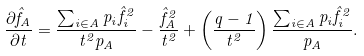Convert formula to latex. <formula><loc_0><loc_0><loc_500><loc_500>\frac { \partial \hat { f } _ { A } } { \partial t } = \frac { \sum _ { i \in A } p _ { i } \hat { f } _ { i } ^ { 2 } } { t ^ { 2 } p _ { A } } - \frac { \hat { f } _ { A } ^ { 2 } } { t ^ { 2 } } + \left ( \frac { q - 1 } { t ^ { 2 } } \right ) \frac { \sum _ { i \in A } p _ { i } \hat { f } ^ { 2 } _ { i } } { p _ { A } } .</formula> 